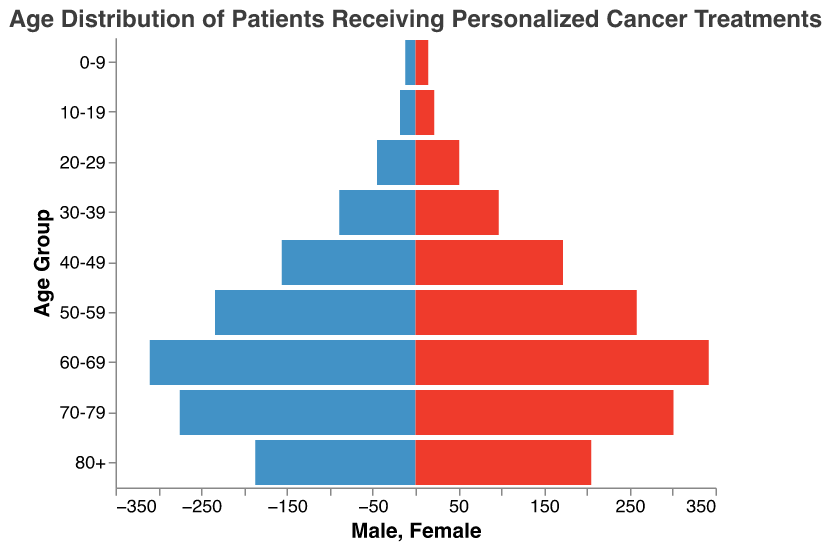What is the title of the figure? The title is displayed at the top of the population pyramid and provides context for the data being visualized. The title reads: "Age Distribution of Patients Receiving Personalized Cancer Treatments".
Answer: Age Distribution of Patients Receiving Personalized Cancer Treatments How many age groups are displayed in the figure? To determine the number of age groups, count the distinct categories along the y-axis representing different age ranges.
Answer: 9 Which age group has the highest number of female patients? From the pyramid, look for the age group bar on the female side (right side) with the greatest length. This corresponds to the age group 60-69, which has 342 female patients.
Answer: 60-69 What is the total number of male patients in the 50-59 age group? Locate the bar corresponding to the 50-59 age group on the male side (left side). The length of this bar represents 234 patients.
Answer: 234 How many more female patients are there compared to male patients in the 70-79 age group? To find the difference, subtract the number of male patients (275) from the number of female patients (301) in the 70-79 age group. Thus, 301 - 275 = 26.
Answer: 26 Comparing the 30-39 age group, are there more male or female patients? Compare the lengths of the bars for the 30-39 age group on both the male and female sides. The female side has a longer bar (97) compared to the male side (89).
Answer: Female Which age group shows the smallest number of patients overall? Find the age group with the shortest combined bar lengths for males and females. This corresponds to the 0-9 age group, with a total of 12 males and 15 females, which sums to 27 patients overall.
Answer: 0-9 What's the total number of patients in the 40-49 age group? Add the number of male and female patients in the 40-49 age group. There are 156 males and 172 females, thus 156 + 172 = 328.
Answer: 328 How many total female patients are depicted across all age groups? Add together all female patient counts for each age group. This is calculated as: 15 + 22 + 51 + 97 + 172 + 258 + 342 + 301 + 205 = 1463.
Answer: 1463 